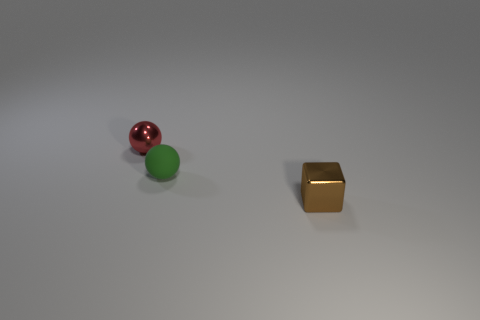Is the material of the thing that is behind the tiny green sphere the same as the small ball in front of the tiny red metal sphere?
Make the answer very short. No. How many other objects are there of the same color as the rubber ball?
Offer a terse response. 0. What number of things are either tiny things that are behind the small brown block or balls that are in front of the red metal thing?
Provide a succinct answer. 2. How big is the green rubber sphere that is in front of the shiny object behind the small green rubber sphere?
Make the answer very short. Small. How big is the metal cube?
Offer a very short reply. Small. There is a small shiny thing left of the brown shiny block; is its color the same as the tiny metallic object that is in front of the metal sphere?
Your answer should be compact. No. What number of other things are there of the same material as the red object
Your answer should be very brief. 1. Are there any tiny green matte objects?
Give a very brief answer. Yes. Is the small ball on the right side of the red thing made of the same material as the tiny brown block?
Provide a succinct answer. No. There is another tiny object that is the same shape as the green thing; what is its material?
Your answer should be very brief. Metal. 